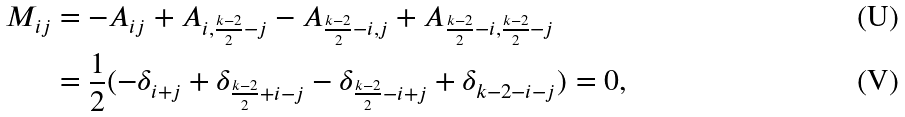Convert formula to latex. <formula><loc_0><loc_0><loc_500><loc_500>M _ { i j } & = - A _ { i j } + A _ { i , \frac { k - 2 } { 2 } - j } - A _ { \frac { k - 2 } { 2 } - i , j } + A _ { \frac { k - 2 } { 2 } - i , \frac { k - 2 } { 2 } - j } \\ & = \frac { 1 } { 2 } ( - \delta _ { i + j } + \delta _ { \frac { k - 2 } { 2 } + i - j } - \delta _ { \frac { k - 2 } { 2 } - i + j } + \delta _ { k - 2 - i - j } ) = 0 \text {,}</formula> 